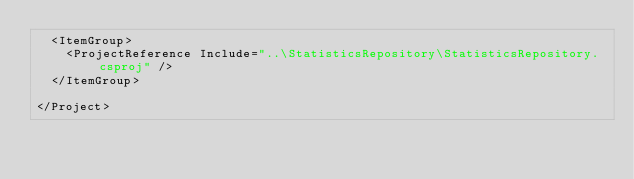Convert code to text. <code><loc_0><loc_0><loc_500><loc_500><_XML_>  <ItemGroup>
    <ProjectReference Include="..\StatisticsRepository\StatisticsRepository.csproj" />
  </ItemGroup>

</Project>
</code> 